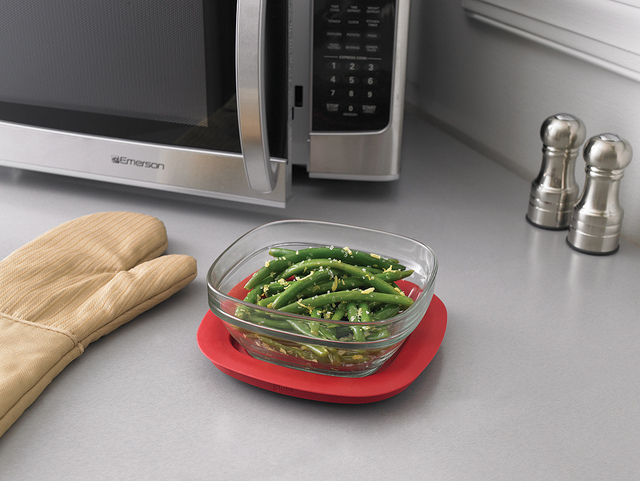How many green veggies are in the bowl? The bowl contains numerous pieces of green beans – unfortunately, the exact count cannot be discerned from this angle. 